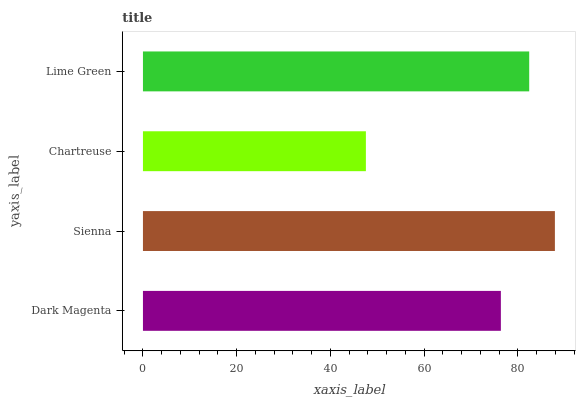Is Chartreuse the minimum?
Answer yes or no. Yes. Is Sienna the maximum?
Answer yes or no. Yes. Is Sienna the minimum?
Answer yes or no. No. Is Chartreuse the maximum?
Answer yes or no. No. Is Sienna greater than Chartreuse?
Answer yes or no. Yes. Is Chartreuse less than Sienna?
Answer yes or no. Yes. Is Chartreuse greater than Sienna?
Answer yes or no. No. Is Sienna less than Chartreuse?
Answer yes or no. No. Is Lime Green the high median?
Answer yes or no. Yes. Is Dark Magenta the low median?
Answer yes or no. Yes. Is Dark Magenta the high median?
Answer yes or no. No. Is Chartreuse the low median?
Answer yes or no. No. 